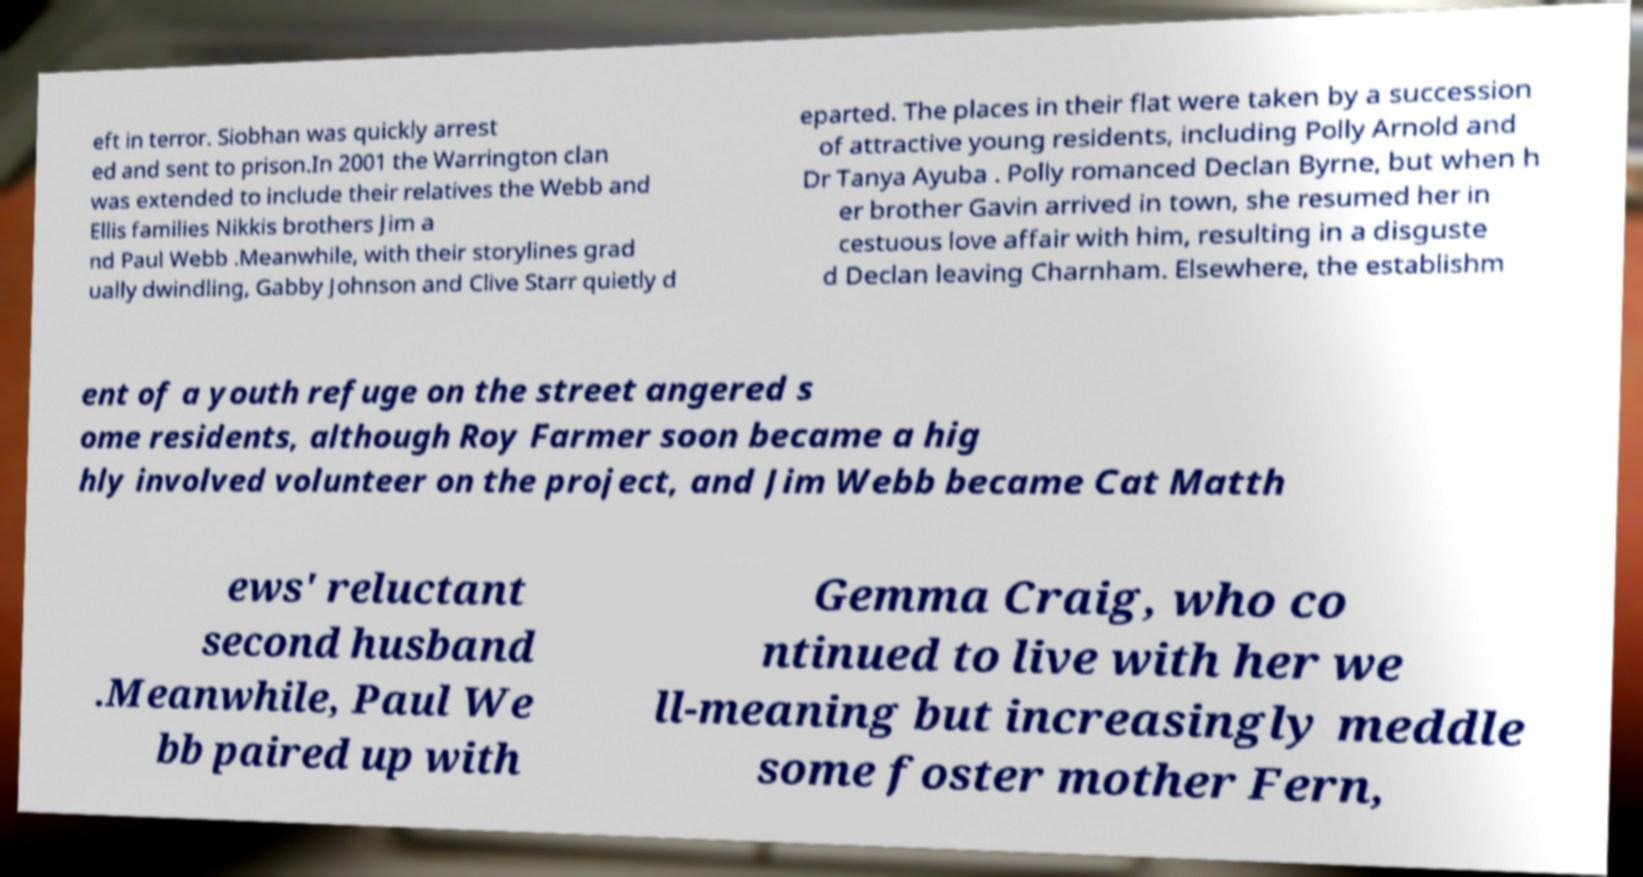For documentation purposes, I need the text within this image transcribed. Could you provide that? eft in terror. Siobhan was quickly arrest ed and sent to prison.In 2001 the Warrington clan was extended to include their relatives the Webb and Ellis families Nikkis brothers Jim a nd Paul Webb .Meanwhile, with their storylines grad ually dwindling, Gabby Johnson and Clive Starr quietly d eparted. The places in their flat were taken by a succession of attractive young residents, including Polly Arnold and Dr Tanya Ayuba . Polly romanced Declan Byrne, but when h er brother Gavin arrived in town, she resumed her in cestuous love affair with him, resulting in a disguste d Declan leaving Charnham. Elsewhere, the establishm ent of a youth refuge on the street angered s ome residents, although Roy Farmer soon became a hig hly involved volunteer on the project, and Jim Webb became Cat Matth ews' reluctant second husband .Meanwhile, Paul We bb paired up with Gemma Craig, who co ntinued to live with her we ll-meaning but increasingly meddle some foster mother Fern, 